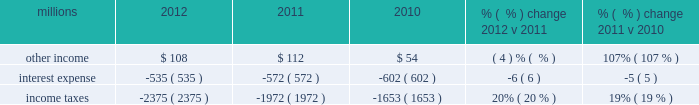Maintenance and contract expenses incurred by our subsidiaries for external transportation services ) ; materials used to maintain the railroad 2019s lines , structures , and equipment ; costs of operating facilities jointly used by uprr and other railroads ; transportation and lodging for train crew employees ; trucking and contracting costs for intermodal containers ; leased automobile maintenance expenses ; and tools and supplies .
Expenses for contract services increased $ 103 million in 2012 versus 2011 , primarily due to increased demand for transportation services purchased by our logistics subsidiaries for their customers and additional costs for repair and maintenance of locomotives and freight cars .
Expenses for contract services increased $ 106 million in 2011 versus 2010 , driven by volume-related external transportation services incurred by our subsidiaries , and various other types of contractual services , including flood-related repairs , mitigation and improvements .
Volume-related crew transportation and lodging costs , as well as expenses associated with jointly owned operating facilities , also increased costs compared to 2010 .
In addition , an increase in locomotive maintenance materials used to prepare a portion of our locomotive fleet for return to active service due to increased volume and additional capacity for weather related issues and warranty expirations increased expenses in 2011 .
Depreciation 2013 the majority of depreciation relates to road property , including rail , ties , ballast , and other track material .
A higher depreciable asset base , reflecting ongoing capital spending , increased depreciation expense in 2012 compared to 2011 .
A higher depreciable asset base , reflecting ongoing capital spending , increased depreciation expense in 2011 compared to 2010 .
Higher depreciation rates for rail and other track material also contributed to the increase .
The higher rates , which became effective january 1 , 2011 , resulted primarily from increased track usage ( based on higher gross ton-miles in 2010 ) .
Equipment and other rents 2013 equipment and other rents expense primarily includes rental expense that the railroad pays for freight cars owned by other railroads or private companies ; freight car , intermodal , and locomotive leases ; and office and other rent expenses .
Increased automotive and intermodal shipments , partially offset by improved car-cycle times , drove an increase in our short-term freight car rental expense in 2012 .
Conversely , lower locomotive lease expense partially offset the higher freight car rental expense .
Costs increased in 2011 versus 2010 as higher short-term freight car rental expense and container lease expense offset lower freight car and locomotive lease expense .
Other 2013 other expenses include personal injury , freight and property damage , destruction of equipment , insurance , environmental , bad debt , state and local taxes , utilities , telephone and cellular , employee travel , computer software , and other general expenses .
Other costs in 2012 were slightly higher than 2011 primarily due to higher property taxes .
Despite continual improvement in our safety experience and lower estimated annual costs , personal injury expense increased in 2012 compared to 2011 , as the liability reduction resulting from historical claim experience was less than the reduction in 2011 .
Higher property taxes , casualty costs associated with destroyed equipment , damaged freight and property and environmental costs increased other costs in 2011 compared to 2010 .
A one-time payment of $ 45 million in the first quarter of 2010 related to a transaction with csxi and continued improvement in our safety performance and lower estimated liability for personal injury , which reduced our personal injury expense year-over-year , partially offset increases in other costs .
Non-operating items millions 2012 2011 2010 % (  % ) change 2012 v 2011 % (  % ) change 2011 v 2010 .
Other income 2013 other income decreased in 2012 versus 2011 due to lower gains from real estate sales and higher environmental costs associated with non-operating properties , partially offset by an interest payment from a tax refund. .
What was the change in other income from 2011 to 2012 in millions? 
Computations: (108 - 112)
Answer: -4.0. 